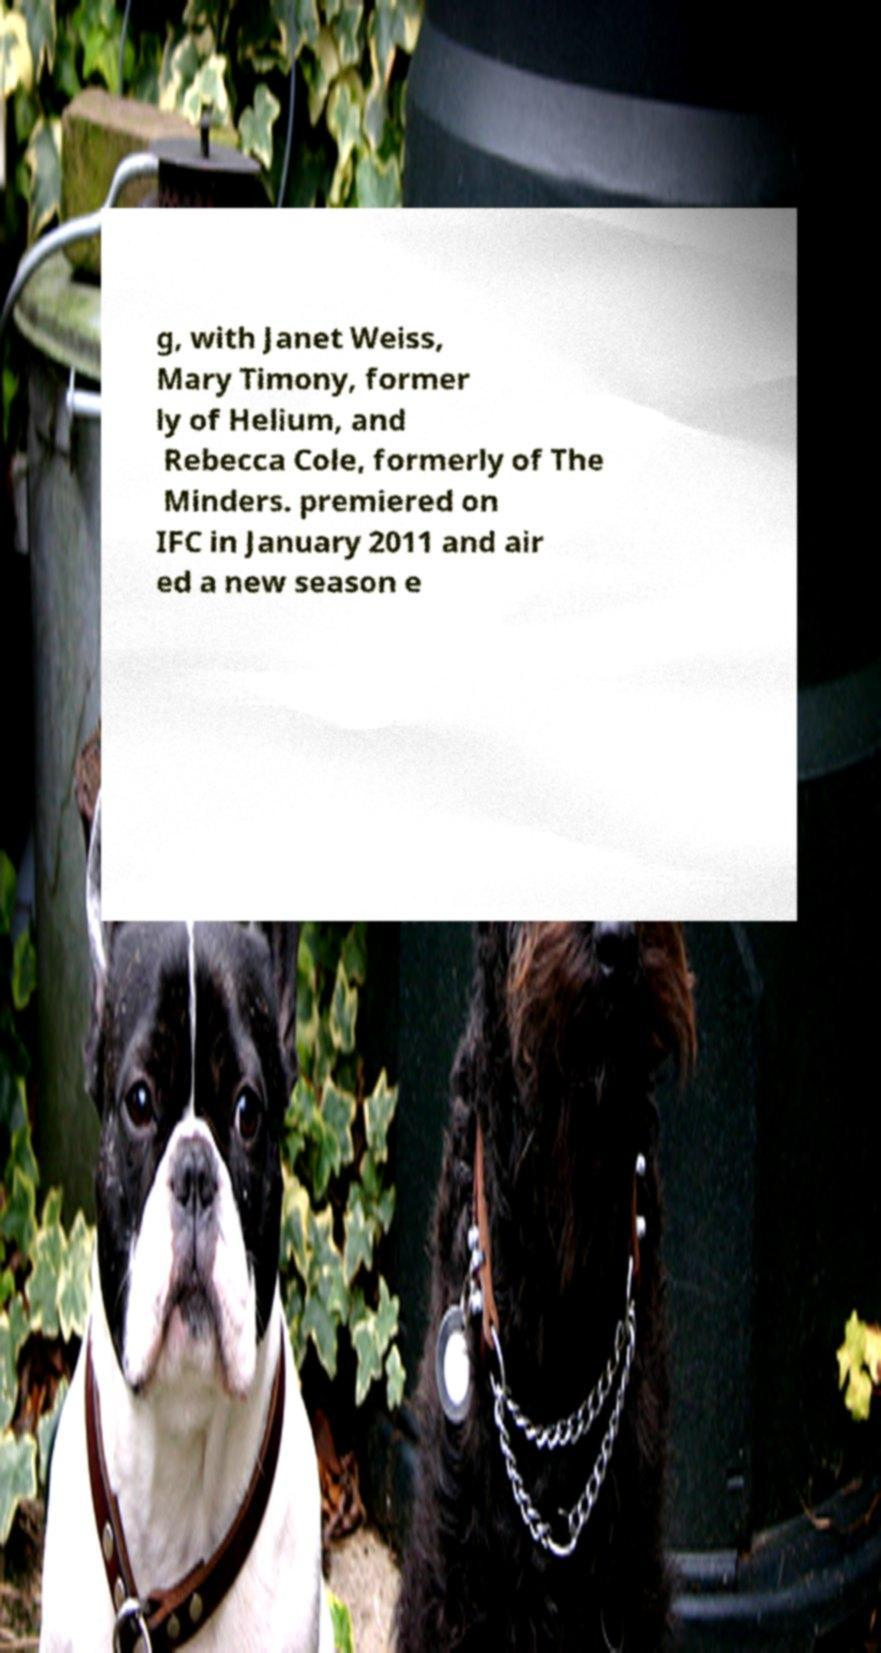For documentation purposes, I need the text within this image transcribed. Could you provide that? g, with Janet Weiss, Mary Timony, former ly of Helium, and Rebecca Cole, formerly of The Minders. premiered on IFC in January 2011 and air ed a new season e 